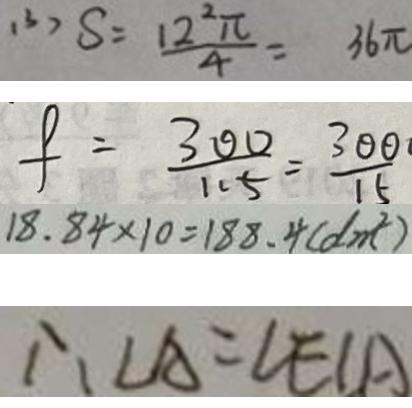Convert formula to latex. <formula><loc_0><loc_0><loc_500><loc_500>( 3 ) S = \frac { 1 2 ^ { 2 } \pi } { 4 } = 3 6 \pi 
 f = \frac { 3 0 0 } { 1 1 5 } = \frac { 3 0 0 } { 1 5 } 
 1 8 . 8 4 \times 1 0 = 1 8 8 . 4 ( d m ^ { 2 } ) 
 \therefore \angle A = \angle E C A</formula> 